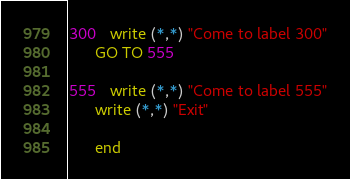<code> <loc_0><loc_0><loc_500><loc_500><_FORTRAN_>300   write (*,*) "Come to label 300"
      GO TO 555

555   write (*,*) "Come to label 555"
      write (*,*) "Exit"

      end
</code> 